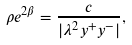Convert formula to latex. <formula><loc_0><loc_0><loc_500><loc_500>\rho e ^ { 2 \beta } = \frac { c } { | \lambda ^ { 2 } y ^ { + } y ^ { - } | } ,</formula> 